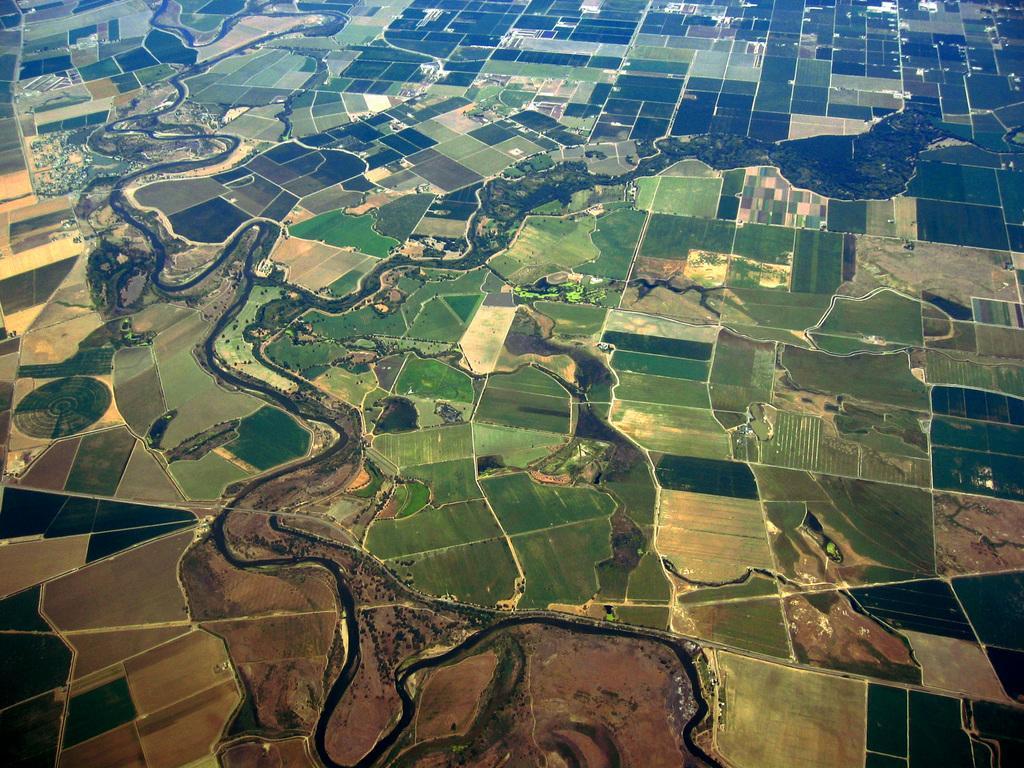Can you describe this image briefly? This is an aerial view where we can see water and agriculture fields. 